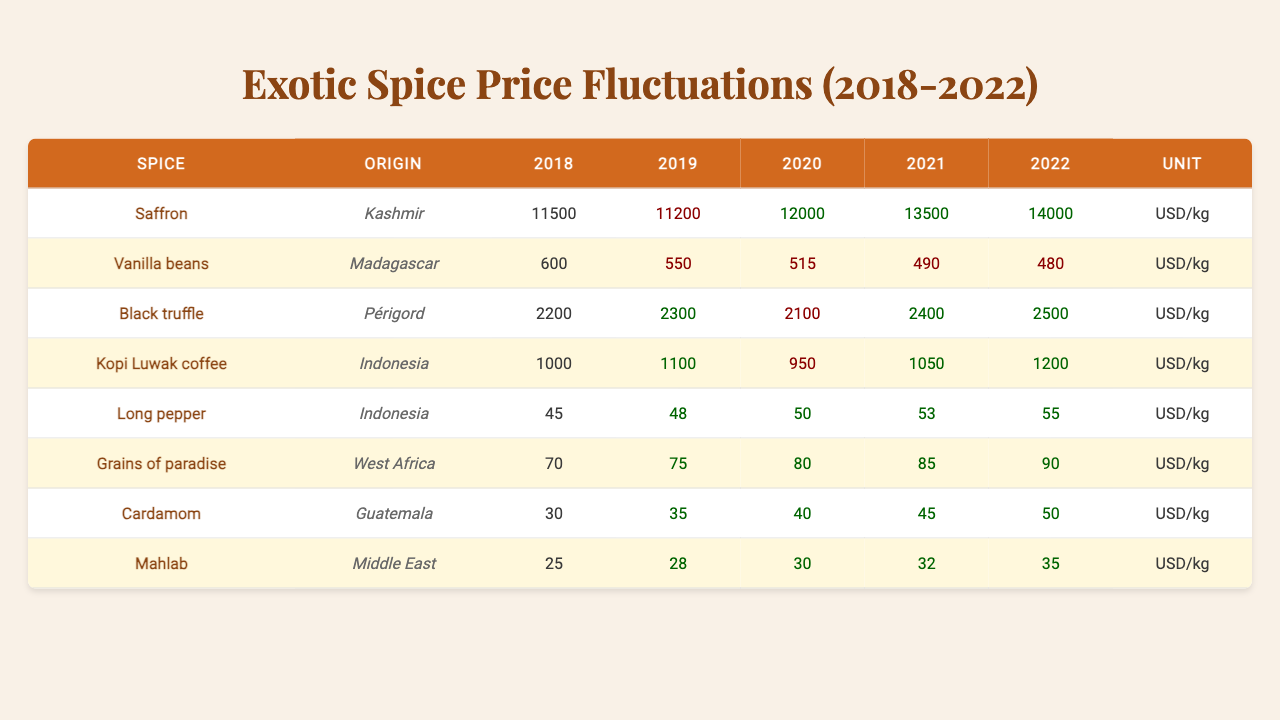What is the price of Saffron in 2020? According to the table, Saffron is listed with a price of 12000 USD/kg for the year 2020.
Answer: 12000 USD/kg Which spice had the highest price in 2022? By examining the prices for each spice in 2022, Saffron is the highest at 14000 USD/kg.
Answer: Saffron What is the percentage increase in the price of Black truffle from 2018 to 2022? The price of Black truffle in 2018 was 2200 USD/kg and in 2022 it was 2500 USD/kg. The increase is calculated as (2500 - 2200) / 2200 * 100 = 13.64%.
Answer: 13.64% Did the price of Vanilla beans decrease in the period from 2018 to 2022? The prices were 600 USD/kg in 2018 and decreased to 480 USD/kg in 2022. This indicates a decrease.
Answer: Yes What was the average price of Cardamom over the five-year period? The prices for Cardamom are 30, 35, 40, 45, and 50 USD/kg. The average is (30 + 35 + 40 + 45 + 50) / 5 = 40 USD/kg.
Answer: 40 USD/kg Which spice experienced the most significant price increase between 2018 and 2022? By comparing the price changes, Saffron increased from 11500 to 14000 USD/kg, resulting in a change of 2500 USD/kg, which is greater than others.
Answer: Saffron Was there a year when the price of Kopi Luwak coffee decreased? Looking at the prices, Kopi Luwak coffee went from 1000 to 950 USD/kg in 2020, indicating a decrease that year.
Answer: Yes What is the total price increase of Grains of paradise from 2018 to 2022? Grains of paradise increased from 70 USD/kg in 2018 to 90 USD/kg in 2022. The total increase is 90 - 70 = 20 USD/kg.
Answer: 20 USD/kg What was the lowest price recorded for Long pepper during this five-year period? Referring to the table, the lowest price for Long pepper is 45 USD/kg, recorded in 2018.
Answer: 45 USD/kg Is the price of Mahlab higher than that of Cardamom in 2022? In 2022, Mahlab was priced at 35 USD/kg and Cardamom at 50 USD/kg. Therefore, Mahlab is lower than Cardamom.
Answer: No What was the median price for all spices in 2021? The prices in 2021 are as follows: Saffron (13500), Vanilla beans (490), Black truffle (2400), Kopi Luwak coffee (1050), Long pepper (53), Grains of paradise (85), Cardamom (45), and Mahlab (32). The median of the ordered list (32, 45, 53, 490, 1050, 2400, 13500) is 85 USD/kg.
Answer: 85 USD/kg 